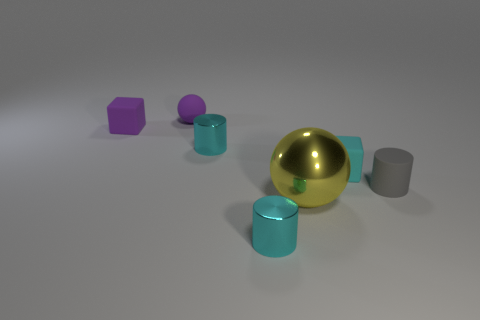Are there any other things that are the same size as the metallic sphere?
Ensure brevity in your answer.  No. Is the number of cyan cylinders that are behind the gray matte cylinder greater than the number of large metal things to the right of the purple sphere?
Keep it short and to the point. No. Is the gray rubber thing the same size as the cyan cube?
Make the answer very short. Yes. What color is the other thing that is the same shape as the big thing?
Keep it short and to the point. Purple. How many tiny cubes have the same color as the large object?
Your answer should be very brief. 0. Are there more blocks on the left side of the purple rubber ball than big gray metallic spheres?
Offer a very short reply. Yes. What color is the rubber cube in front of the thing to the left of the small sphere?
Your answer should be very brief. Cyan. How many objects are matte things that are behind the tiny cyan matte block or tiny cyan objects behind the large yellow object?
Your answer should be compact. 4. What color is the tiny matte cylinder?
Give a very brief answer. Gray. What number of tiny spheres have the same material as the purple block?
Keep it short and to the point. 1. 